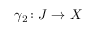<formula> <loc_0><loc_0><loc_500><loc_500>\gamma _ { 2 } \colon J \rightarrow X</formula> 